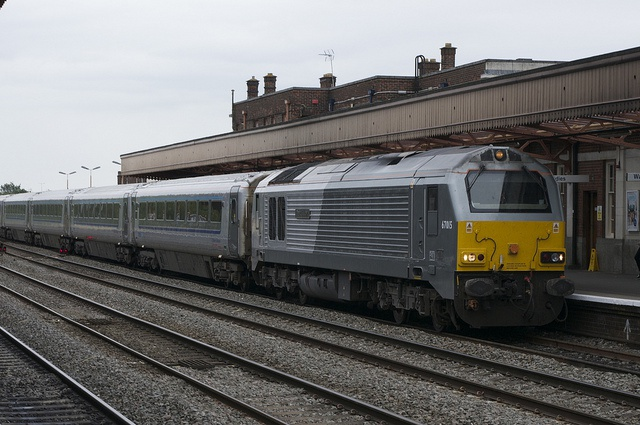Describe the objects in this image and their specific colors. I can see a train in black, gray, and darkgray tones in this image. 